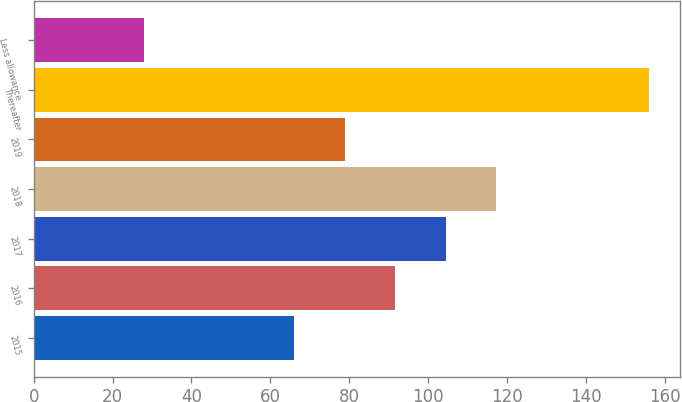Convert chart. <chart><loc_0><loc_0><loc_500><loc_500><bar_chart><fcel>2015<fcel>2016<fcel>2017<fcel>2018<fcel>2019<fcel>Thereafter<fcel>Less allowance<nl><fcel>66<fcel>91.6<fcel>104.4<fcel>117.2<fcel>78.8<fcel>156<fcel>28<nl></chart> 